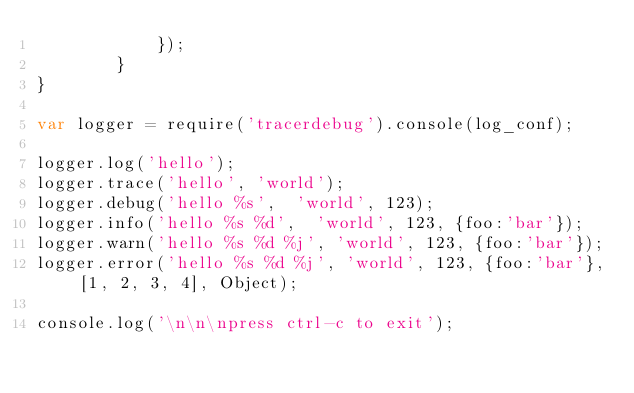<code> <loc_0><loc_0><loc_500><loc_500><_JavaScript_>			});
		}
}

var logger = require('tracerdebug').console(log_conf);

logger.log('hello');
logger.trace('hello', 'world');
logger.debug('hello %s',  'world', 123);
logger.info('hello %s %d',  'world', 123, {foo:'bar'});
logger.warn('hello %s %d %j', 'world', 123, {foo:'bar'});
logger.error('hello %s %d %j', 'world', 123, {foo:'bar'}, [1, 2, 3, 4], Object);

console.log('\n\n\npress ctrl-c to exit');
</code> 